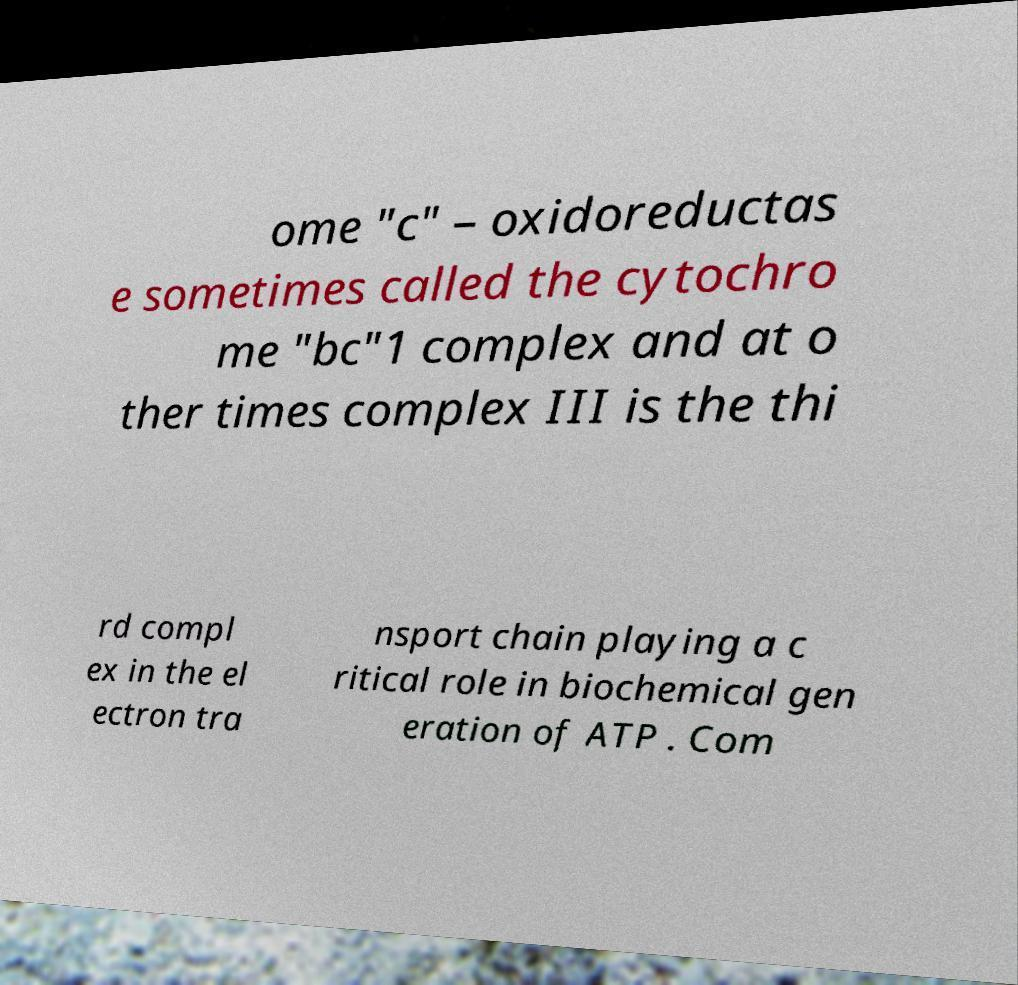Please read and relay the text visible in this image. What does it say? ome "c" – oxidoreductas e sometimes called the cytochro me "bc"1 complex and at o ther times complex III is the thi rd compl ex in the el ectron tra nsport chain playing a c ritical role in biochemical gen eration of ATP . Com 